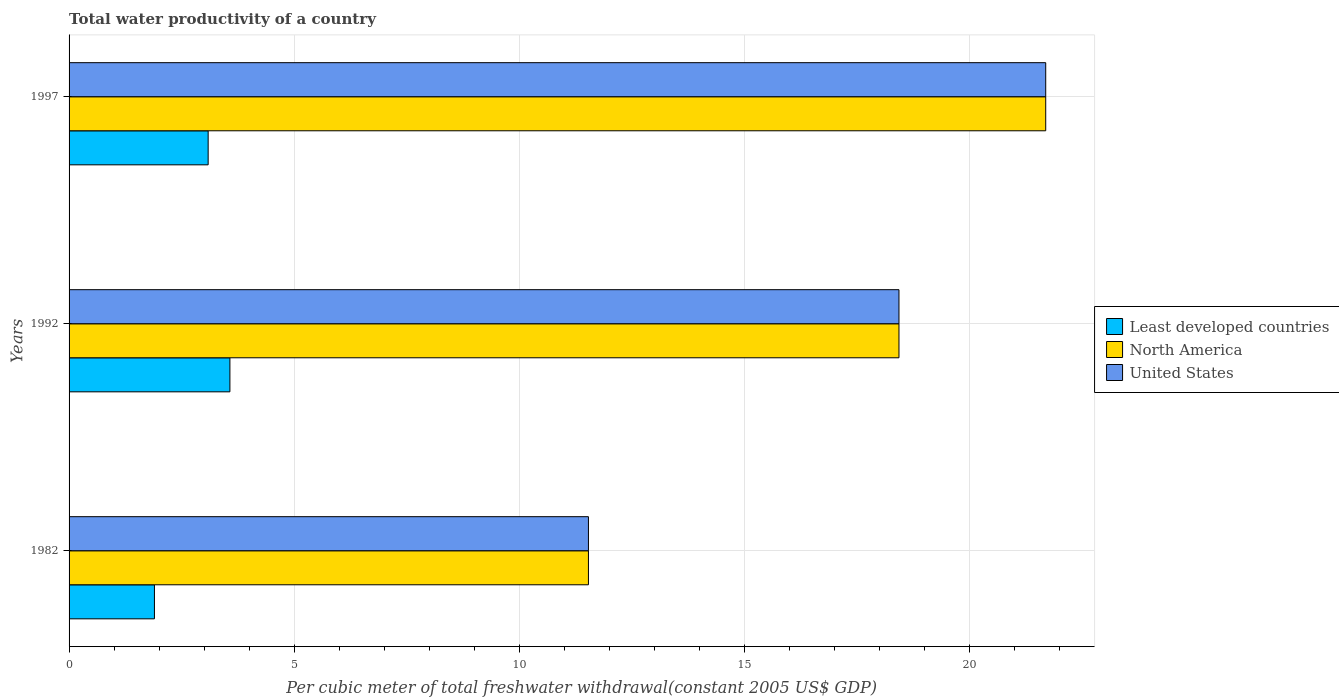How many different coloured bars are there?
Your answer should be compact. 3. Are the number of bars per tick equal to the number of legend labels?
Your answer should be compact. Yes. Are the number of bars on each tick of the Y-axis equal?
Ensure brevity in your answer.  Yes. How many bars are there on the 3rd tick from the bottom?
Provide a short and direct response. 3. What is the total water productivity in North America in 1992?
Your response must be concise. 18.43. Across all years, what is the maximum total water productivity in Least developed countries?
Offer a very short reply. 3.57. Across all years, what is the minimum total water productivity in Least developed countries?
Ensure brevity in your answer.  1.9. In which year was the total water productivity in North America maximum?
Provide a succinct answer. 1997. In which year was the total water productivity in Least developed countries minimum?
Keep it short and to the point. 1982. What is the total total water productivity in North America in the graph?
Provide a succinct answer. 51.65. What is the difference between the total water productivity in United States in 1982 and that in 1997?
Provide a succinct answer. -10.16. What is the difference between the total water productivity in United States in 1997 and the total water productivity in North America in 1982?
Make the answer very short. 10.16. What is the average total water productivity in Least developed countries per year?
Your response must be concise. 2.85. In the year 1992, what is the difference between the total water productivity in North America and total water productivity in United States?
Offer a very short reply. 0. In how many years, is the total water productivity in Least developed countries greater than 6 US$?
Ensure brevity in your answer.  0. What is the ratio of the total water productivity in Least developed countries in 1982 to that in 1992?
Provide a succinct answer. 0.53. Is the total water productivity in Least developed countries in 1982 less than that in 1992?
Ensure brevity in your answer.  Yes. What is the difference between the highest and the second highest total water productivity in Least developed countries?
Offer a very short reply. 0.48. What is the difference between the highest and the lowest total water productivity in Least developed countries?
Your response must be concise. 1.68. In how many years, is the total water productivity in United States greater than the average total water productivity in United States taken over all years?
Ensure brevity in your answer.  2. What does the 3rd bar from the top in 1982 represents?
Provide a succinct answer. Least developed countries. What does the 2nd bar from the bottom in 1982 represents?
Keep it short and to the point. North America. Is it the case that in every year, the sum of the total water productivity in United States and total water productivity in Least developed countries is greater than the total water productivity in North America?
Your answer should be compact. Yes. How many bars are there?
Provide a succinct answer. 9. Are all the bars in the graph horizontal?
Provide a short and direct response. Yes. What is the difference between two consecutive major ticks on the X-axis?
Your answer should be very brief. 5. Are the values on the major ticks of X-axis written in scientific E-notation?
Your answer should be compact. No. Does the graph contain grids?
Your response must be concise. Yes. Where does the legend appear in the graph?
Offer a very short reply. Center right. How many legend labels are there?
Give a very brief answer. 3. What is the title of the graph?
Provide a succinct answer. Total water productivity of a country. Does "St. Martin (French part)" appear as one of the legend labels in the graph?
Offer a very short reply. No. What is the label or title of the X-axis?
Ensure brevity in your answer.  Per cubic meter of total freshwater withdrawal(constant 2005 US$ GDP). What is the label or title of the Y-axis?
Offer a terse response. Years. What is the Per cubic meter of total freshwater withdrawal(constant 2005 US$ GDP) in Least developed countries in 1982?
Your response must be concise. 1.9. What is the Per cubic meter of total freshwater withdrawal(constant 2005 US$ GDP) of North America in 1982?
Provide a short and direct response. 11.53. What is the Per cubic meter of total freshwater withdrawal(constant 2005 US$ GDP) of United States in 1982?
Provide a succinct answer. 11.53. What is the Per cubic meter of total freshwater withdrawal(constant 2005 US$ GDP) of Least developed countries in 1992?
Give a very brief answer. 3.57. What is the Per cubic meter of total freshwater withdrawal(constant 2005 US$ GDP) of North America in 1992?
Give a very brief answer. 18.43. What is the Per cubic meter of total freshwater withdrawal(constant 2005 US$ GDP) in United States in 1992?
Keep it short and to the point. 18.43. What is the Per cubic meter of total freshwater withdrawal(constant 2005 US$ GDP) in Least developed countries in 1997?
Offer a terse response. 3.09. What is the Per cubic meter of total freshwater withdrawal(constant 2005 US$ GDP) in North America in 1997?
Offer a very short reply. 21.69. What is the Per cubic meter of total freshwater withdrawal(constant 2005 US$ GDP) in United States in 1997?
Give a very brief answer. 21.69. Across all years, what is the maximum Per cubic meter of total freshwater withdrawal(constant 2005 US$ GDP) in Least developed countries?
Ensure brevity in your answer.  3.57. Across all years, what is the maximum Per cubic meter of total freshwater withdrawal(constant 2005 US$ GDP) of North America?
Your response must be concise. 21.69. Across all years, what is the maximum Per cubic meter of total freshwater withdrawal(constant 2005 US$ GDP) in United States?
Ensure brevity in your answer.  21.69. Across all years, what is the minimum Per cubic meter of total freshwater withdrawal(constant 2005 US$ GDP) in Least developed countries?
Offer a very short reply. 1.9. Across all years, what is the minimum Per cubic meter of total freshwater withdrawal(constant 2005 US$ GDP) in North America?
Your response must be concise. 11.53. Across all years, what is the minimum Per cubic meter of total freshwater withdrawal(constant 2005 US$ GDP) of United States?
Your answer should be very brief. 11.53. What is the total Per cubic meter of total freshwater withdrawal(constant 2005 US$ GDP) in Least developed countries in the graph?
Provide a succinct answer. 8.56. What is the total Per cubic meter of total freshwater withdrawal(constant 2005 US$ GDP) in North America in the graph?
Your answer should be compact. 51.65. What is the total Per cubic meter of total freshwater withdrawal(constant 2005 US$ GDP) in United States in the graph?
Your answer should be very brief. 51.65. What is the difference between the Per cubic meter of total freshwater withdrawal(constant 2005 US$ GDP) of Least developed countries in 1982 and that in 1992?
Offer a very short reply. -1.68. What is the difference between the Per cubic meter of total freshwater withdrawal(constant 2005 US$ GDP) in North America in 1982 and that in 1992?
Your answer should be very brief. -6.9. What is the difference between the Per cubic meter of total freshwater withdrawal(constant 2005 US$ GDP) in United States in 1982 and that in 1992?
Offer a very short reply. -6.9. What is the difference between the Per cubic meter of total freshwater withdrawal(constant 2005 US$ GDP) of Least developed countries in 1982 and that in 1997?
Provide a succinct answer. -1.19. What is the difference between the Per cubic meter of total freshwater withdrawal(constant 2005 US$ GDP) in North America in 1982 and that in 1997?
Offer a very short reply. -10.16. What is the difference between the Per cubic meter of total freshwater withdrawal(constant 2005 US$ GDP) of United States in 1982 and that in 1997?
Provide a succinct answer. -10.16. What is the difference between the Per cubic meter of total freshwater withdrawal(constant 2005 US$ GDP) of Least developed countries in 1992 and that in 1997?
Offer a terse response. 0.48. What is the difference between the Per cubic meter of total freshwater withdrawal(constant 2005 US$ GDP) in North America in 1992 and that in 1997?
Your answer should be very brief. -3.26. What is the difference between the Per cubic meter of total freshwater withdrawal(constant 2005 US$ GDP) of United States in 1992 and that in 1997?
Offer a very short reply. -3.26. What is the difference between the Per cubic meter of total freshwater withdrawal(constant 2005 US$ GDP) of Least developed countries in 1982 and the Per cubic meter of total freshwater withdrawal(constant 2005 US$ GDP) of North America in 1992?
Offer a terse response. -16.53. What is the difference between the Per cubic meter of total freshwater withdrawal(constant 2005 US$ GDP) in Least developed countries in 1982 and the Per cubic meter of total freshwater withdrawal(constant 2005 US$ GDP) in United States in 1992?
Ensure brevity in your answer.  -16.53. What is the difference between the Per cubic meter of total freshwater withdrawal(constant 2005 US$ GDP) of North America in 1982 and the Per cubic meter of total freshwater withdrawal(constant 2005 US$ GDP) of United States in 1992?
Offer a very short reply. -6.9. What is the difference between the Per cubic meter of total freshwater withdrawal(constant 2005 US$ GDP) in Least developed countries in 1982 and the Per cubic meter of total freshwater withdrawal(constant 2005 US$ GDP) in North America in 1997?
Make the answer very short. -19.79. What is the difference between the Per cubic meter of total freshwater withdrawal(constant 2005 US$ GDP) in Least developed countries in 1982 and the Per cubic meter of total freshwater withdrawal(constant 2005 US$ GDP) in United States in 1997?
Provide a succinct answer. -19.79. What is the difference between the Per cubic meter of total freshwater withdrawal(constant 2005 US$ GDP) of North America in 1982 and the Per cubic meter of total freshwater withdrawal(constant 2005 US$ GDP) of United States in 1997?
Offer a very short reply. -10.16. What is the difference between the Per cubic meter of total freshwater withdrawal(constant 2005 US$ GDP) in Least developed countries in 1992 and the Per cubic meter of total freshwater withdrawal(constant 2005 US$ GDP) in North America in 1997?
Ensure brevity in your answer.  -18.12. What is the difference between the Per cubic meter of total freshwater withdrawal(constant 2005 US$ GDP) in Least developed countries in 1992 and the Per cubic meter of total freshwater withdrawal(constant 2005 US$ GDP) in United States in 1997?
Provide a short and direct response. -18.12. What is the difference between the Per cubic meter of total freshwater withdrawal(constant 2005 US$ GDP) of North America in 1992 and the Per cubic meter of total freshwater withdrawal(constant 2005 US$ GDP) of United States in 1997?
Offer a very short reply. -3.26. What is the average Per cubic meter of total freshwater withdrawal(constant 2005 US$ GDP) of Least developed countries per year?
Offer a very short reply. 2.85. What is the average Per cubic meter of total freshwater withdrawal(constant 2005 US$ GDP) in North America per year?
Your answer should be compact. 17.22. What is the average Per cubic meter of total freshwater withdrawal(constant 2005 US$ GDP) in United States per year?
Ensure brevity in your answer.  17.22. In the year 1982, what is the difference between the Per cubic meter of total freshwater withdrawal(constant 2005 US$ GDP) in Least developed countries and Per cubic meter of total freshwater withdrawal(constant 2005 US$ GDP) in North America?
Provide a short and direct response. -9.64. In the year 1982, what is the difference between the Per cubic meter of total freshwater withdrawal(constant 2005 US$ GDP) in Least developed countries and Per cubic meter of total freshwater withdrawal(constant 2005 US$ GDP) in United States?
Give a very brief answer. -9.64. In the year 1982, what is the difference between the Per cubic meter of total freshwater withdrawal(constant 2005 US$ GDP) of North America and Per cubic meter of total freshwater withdrawal(constant 2005 US$ GDP) of United States?
Provide a short and direct response. 0. In the year 1992, what is the difference between the Per cubic meter of total freshwater withdrawal(constant 2005 US$ GDP) of Least developed countries and Per cubic meter of total freshwater withdrawal(constant 2005 US$ GDP) of North America?
Provide a short and direct response. -14.86. In the year 1992, what is the difference between the Per cubic meter of total freshwater withdrawal(constant 2005 US$ GDP) in Least developed countries and Per cubic meter of total freshwater withdrawal(constant 2005 US$ GDP) in United States?
Your answer should be very brief. -14.86. In the year 1997, what is the difference between the Per cubic meter of total freshwater withdrawal(constant 2005 US$ GDP) of Least developed countries and Per cubic meter of total freshwater withdrawal(constant 2005 US$ GDP) of North America?
Make the answer very short. -18.6. In the year 1997, what is the difference between the Per cubic meter of total freshwater withdrawal(constant 2005 US$ GDP) in Least developed countries and Per cubic meter of total freshwater withdrawal(constant 2005 US$ GDP) in United States?
Your answer should be very brief. -18.6. In the year 1997, what is the difference between the Per cubic meter of total freshwater withdrawal(constant 2005 US$ GDP) in North America and Per cubic meter of total freshwater withdrawal(constant 2005 US$ GDP) in United States?
Your response must be concise. 0. What is the ratio of the Per cubic meter of total freshwater withdrawal(constant 2005 US$ GDP) in Least developed countries in 1982 to that in 1992?
Provide a short and direct response. 0.53. What is the ratio of the Per cubic meter of total freshwater withdrawal(constant 2005 US$ GDP) in North America in 1982 to that in 1992?
Keep it short and to the point. 0.63. What is the ratio of the Per cubic meter of total freshwater withdrawal(constant 2005 US$ GDP) of United States in 1982 to that in 1992?
Keep it short and to the point. 0.63. What is the ratio of the Per cubic meter of total freshwater withdrawal(constant 2005 US$ GDP) in Least developed countries in 1982 to that in 1997?
Your answer should be compact. 0.61. What is the ratio of the Per cubic meter of total freshwater withdrawal(constant 2005 US$ GDP) of North America in 1982 to that in 1997?
Give a very brief answer. 0.53. What is the ratio of the Per cubic meter of total freshwater withdrawal(constant 2005 US$ GDP) of United States in 1982 to that in 1997?
Ensure brevity in your answer.  0.53. What is the ratio of the Per cubic meter of total freshwater withdrawal(constant 2005 US$ GDP) in Least developed countries in 1992 to that in 1997?
Keep it short and to the point. 1.16. What is the ratio of the Per cubic meter of total freshwater withdrawal(constant 2005 US$ GDP) in North America in 1992 to that in 1997?
Ensure brevity in your answer.  0.85. What is the ratio of the Per cubic meter of total freshwater withdrawal(constant 2005 US$ GDP) of United States in 1992 to that in 1997?
Offer a very short reply. 0.85. What is the difference between the highest and the second highest Per cubic meter of total freshwater withdrawal(constant 2005 US$ GDP) in Least developed countries?
Make the answer very short. 0.48. What is the difference between the highest and the second highest Per cubic meter of total freshwater withdrawal(constant 2005 US$ GDP) of North America?
Offer a very short reply. 3.26. What is the difference between the highest and the second highest Per cubic meter of total freshwater withdrawal(constant 2005 US$ GDP) in United States?
Give a very brief answer. 3.26. What is the difference between the highest and the lowest Per cubic meter of total freshwater withdrawal(constant 2005 US$ GDP) in Least developed countries?
Keep it short and to the point. 1.68. What is the difference between the highest and the lowest Per cubic meter of total freshwater withdrawal(constant 2005 US$ GDP) of North America?
Make the answer very short. 10.16. What is the difference between the highest and the lowest Per cubic meter of total freshwater withdrawal(constant 2005 US$ GDP) in United States?
Keep it short and to the point. 10.16. 